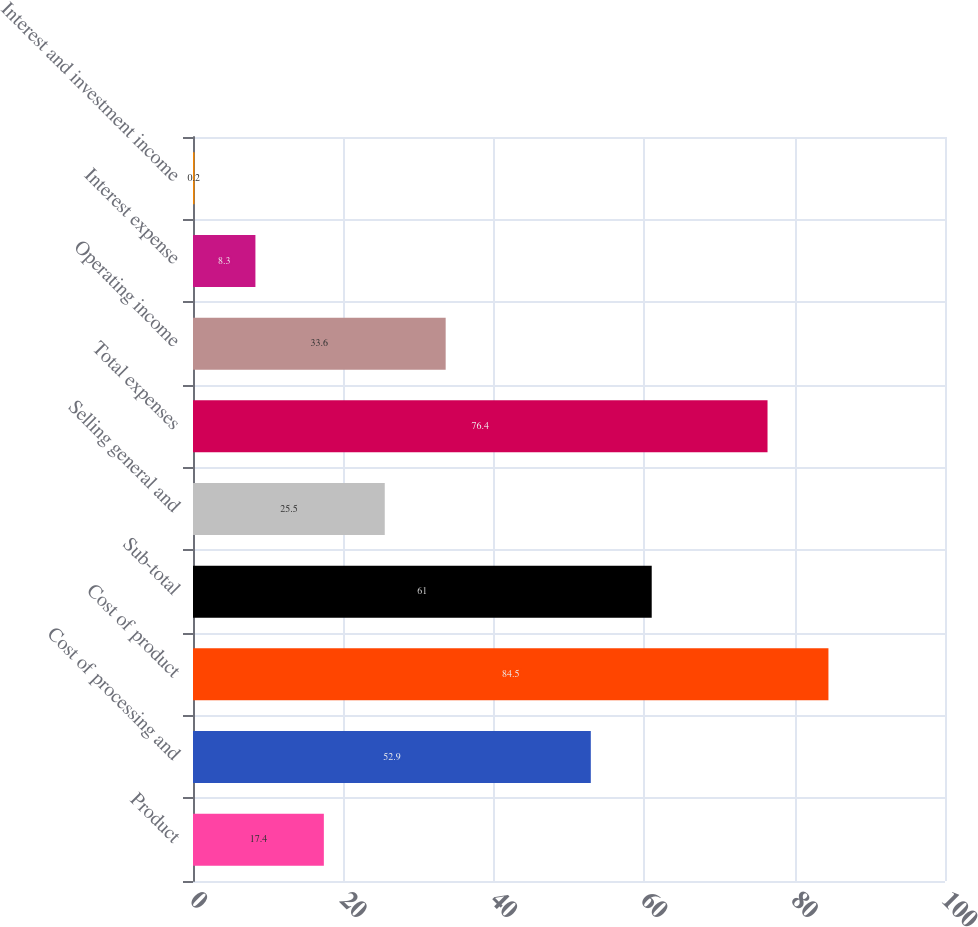Convert chart to OTSL. <chart><loc_0><loc_0><loc_500><loc_500><bar_chart><fcel>Product<fcel>Cost of processing and<fcel>Cost of product<fcel>Sub-total<fcel>Selling general and<fcel>Total expenses<fcel>Operating income<fcel>Interest expense<fcel>Interest and investment income<nl><fcel>17.4<fcel>52.9<fcel>84.5<fcel>61<fcel>25.5<fcel>76.4<fcel>33.6<fcel>8.3<fcel>0.2<nl></chart> 